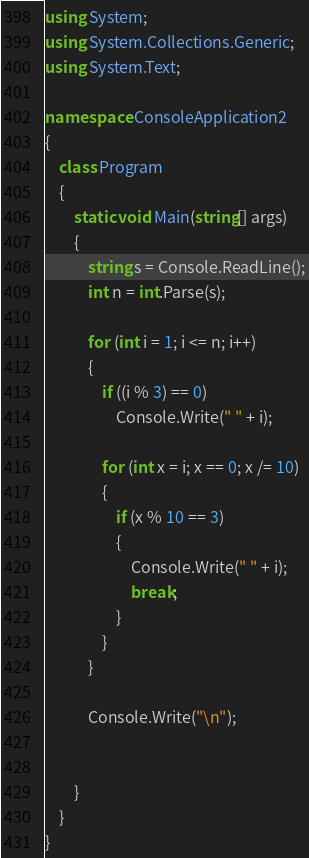<code> <loc_0><loc_0><loc_500><loc_500><_C#_>using System;
using System.Collections.Generic;
using System.Text;

namespace ConsoleApplication2
{
    class Program
    {
        static void Main(string[] args)
        {
            string s = Console.ReadLine();
            int n = int.Parse(s);

            for (int i = 1; i <= n; i++)
            {
                if ((i % 3) == 0)
                    Console.Write(" " + i);

                for (int x = i; x == 0; x /= 10)
                {
                    if (x % 10 == 3)
                    {
                        Console.Write(" " + i);
                        break;
                    }
                }
            }

            Console.Write("\n");


        }
    }
}</code> 